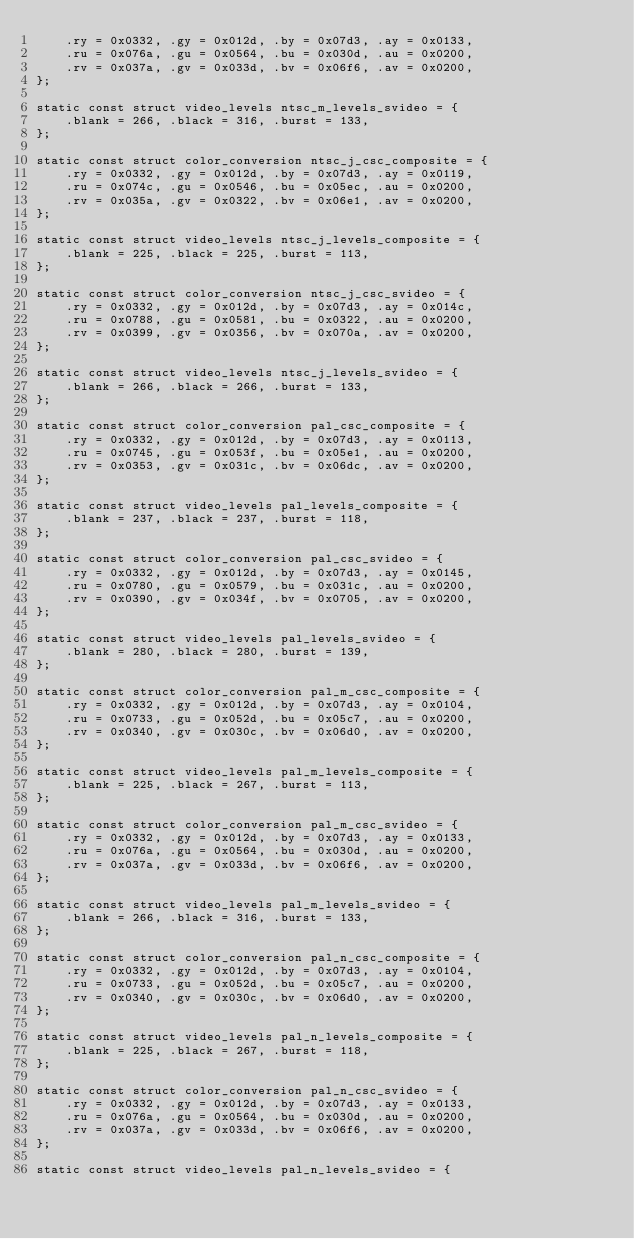<code> <loc_0><loc_0><loc_500><loc_500><_C_>	.ry = 0x0332, .gy = 0x012d, .by = 0x07d3, .ay = 0x0133,
	.ru = 0x076a, .gu = 0x0564, .bu = 0x030d, .au = 0x0200,
	.rv = 0x037a, .gv = 0x033d, .bv = 0x06f6, .av = 0x0200,
};

static const struct video_levels ntsc_m_levels_svideo = {
	.blank = 266, .black = 316, .burst = 133,
};

static const struct color_conversion ntsc_j_csc_composite = {
	.ry = 0x0332, .gy = 0x012d, .by = 0x07d3, .ay = 0x0119,
	.ru = 0x074c, .gu = 0x0546, .bu = 0x05ec, .au = 0x0200,
	.rv = 0x035a, .gv = 0x0322, .bv = 0x06e1, .av = 0x0200,
};

static const struct video_levels ntsc_j_levels_composite = {
	.blank = 225, .black = 225, .burst = 113,
};

static const struct color_conversion ntsc_j_csc_svideo = {
	.ry = 0x0332, .gy = 0x012d, .by = 0x07d3, .ay = 0x014c,
	.ru = 0x0788, .gu = 0x0581, .bu = 0x0322, .au = 0x0200,
	.rv = 0x0399, .gv = 0x0356, .bv = 0x070a, .av = 0x0200,
};

static const struct video_levels ntsc_j_levels_svideo = {
	.blank = 266, .black = 266, .burst = 133,
};

static const struct color_conversion pal_csc_composite = {
	.ry = 0x0332, .gy = 0x012d, .by = 0x07d3, .ay = 0x0113,
	.ru = 0x0745, .gu = 0x053f, .bu = 0x05e1, .au = 0x0200,
	.rv = 0x0353, .gv = 0x031c, .bv = 0x06dc, .av = 0x0200,
};

static const struct video_levels pal_levels_composite = {
	.blank = 237, .black = 237, .burst = 118,
};

static const struct color_conversion pal_csc_svideo = {
	.ry = 0x0332, .gy = 0x012d, .by = 0x07d3, .ay = 0x0145,
	.ru = 0x0780, .gu = 0x0579, .bu = 0x031c, .au = 0x0200,
	.rv = 0x0390, .gv = 0x034f, .bv = 0x0705, .av = 0x0200,
};

static const struct video_levels pal_levels_svideo = {
	.blank = 280, .black = 280, .burst = 139,
};

static const struct color_conversion pal_m_csc_composite = {
	.ry = 0x0332, .gy = 0x012d, .by = 0x07d3, .ay = 0x0104,
	.ru = 0x0733, .gu = 0x052d, .bu = 0x05c7, .au = 0x0200,
	.rv = 0x0340, .gv = 0x030c, .bv = 0x06d0, .av = 0x0200,
};

static const struct video_levels pal_m_levels_composite = {
	.blank = 225, .black = 267, .burst = 113,
};

static const struct color_conversion pal_m_csc_svideo = {
	.ry = 0x0332, .gy = 0x012d, .by = 0x07d3, .ay = 0x0133,
	.ru = 0x076a, .gu = 0x0564, .bu = 0x030d, .au = 0x0200,
	.rv = 0x037a, .gv = 0x033d, .bv = 0x06f6, .av = 0x0200,
};

static const struct video_levels pal_m_levels_svideo = {
	.blank = 266, .black = 316, .burst = 133,
};

static const struct color_conversion pal_n_csc_composite = {
	.ry = 0x0332, .gy = 0x012d, .by = 0x07d3, .ay = 0x0104,
	.ru = 0x0733, .gu = 0x052d, .bu = 0x05c7, .au = 0x0200,
	.rv = 0x0340, .gv = 0x030c, .bv = 0x06d0, .av = 0x0200,
};

static const struct video_levels pal_n_levels_composite = {
	.blank = 225, .black = 267, .burst = 118,
};

static const struct color_conversion pal_n_csc_svideo = {
	.ry = 0x0332, .gy = 0x012d, .by = 0x07d3, .ay = 0x0133,
	.ru = 0x076a, .gu = 0x0564, .bu = 0x030d, .au = 0x0200,
	.rv = 0x037a, .gv = 0x033d, .bv = 0x06f6, .av = 0x0200,
};

static const struct video_levels pal_n_levels_svideo = {</code> 